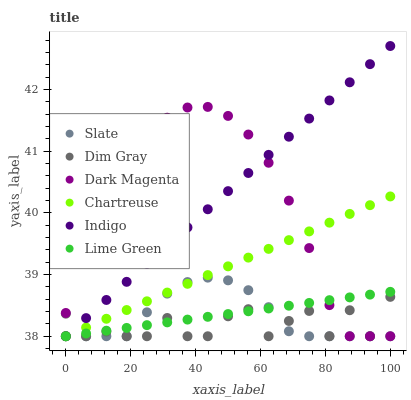Does Dim Gray have the minimum area under the curve?
Answer yes or no. Yes. Does Indigo have the maximum area under the curve?
Answer yes or no. Yes. Does Dark Magenta have the minimum area under the curve?
Answer yes or no. No. Does Dark Magenta have the maximum area under the curve?
Answer yes or no. No. Is Chartreuse the smoothest?
Answer yes or no. Yes. Is Dim Gray the roughest?
Answer yes or no. Yes. Is Indigo the smoothest?
Answer yes or no. No. Is Indigo the roughest?
Answer yes or no. No. Does Dim Gray have the lowest value?
Answer yes or no. Yes. Does Indigo have the highest value?
Answer yes or no. Yes. Does Dark Magenta have the highest value?
Answer yes or no. No. Does Dark Magenta intersect Chartreuse?
Answer yes or no. Yes. Is Dark Magenta less than Chartreuse?
Answer yes or no. No. Is Dark Magenta greater than Chartreuse?
Answer yes or no. No. 